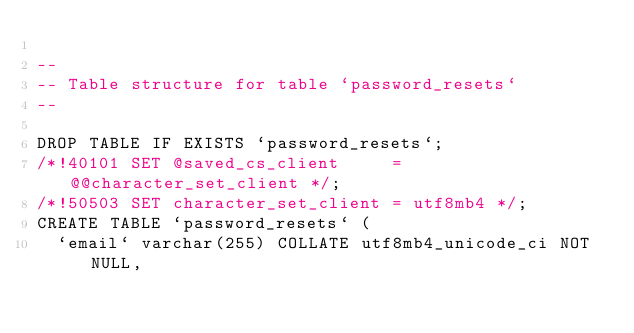Convert code to text. <code><loc_0><loc_0><loc_500><loc_500><_SQL_>
--
-- Table structure for table `password_resets`
--

DROP TABLE IF EXISTS `password_resets`;
/*!40101 SET @saved_cs_client     = @@character_set_client */;
/*!50503 SET character_set_client = utf8mb4 */;
CREATE TABLE `password_resets` (
  `email` varchar(255) COLLATE utf8mb4_unicode_ci NOT NULL,</code> 